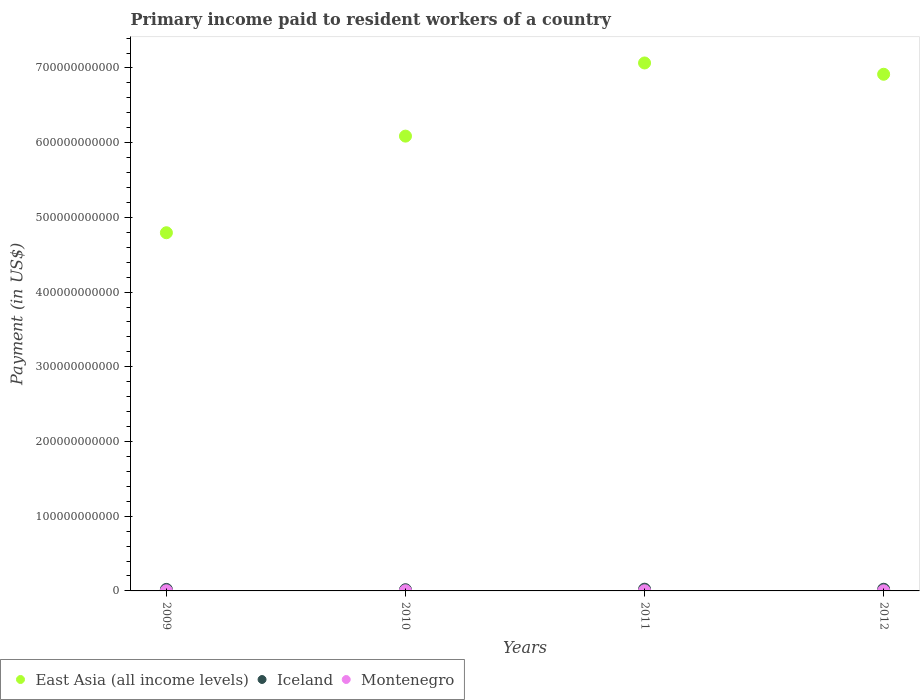Is the number of dotlines equal to the number of legend labels?
Ensure brevity in your answer.  Yes. What is the amount paid to workers in Iceland in 2011?
Provide a succinct answer. 2.31e+09. Across all years, what is the maximum amount paid to workers in Iceland?
Keep it short and to the point. 2.31e+09. Across all years, what is the minimum amount paid to workers in Iceland?
Give a very brief answer. 1.63e+09. In which year was the amount paid to workers in Iceland minimum?
Give a very brief answer. 2010. What is the total amount paid to workers in Iceland in the graph?
Provide a succinct answer. 8.19e+09. What is the difference between the amount paid to workers in Montenegro in 2009 and that in 2012?
Ensure brevity in your answer.  2.44e+07. What is the difference between the amount paid to workers in Iceland in 2011 and the amount paid to workers in Montenegro in 2012?
Provide a short and direct response. 2.12e+09. What is the average amount paid to workers in Montenegro per year?
Your answer should be very brief. 2.24e+08. In the year 2012, what is the difference between the amount paid to workers in Montenegro and amount paid to workers in Iceland?
Offer a very short reply. -2.03e+09. In how many years, is the amount paid to workers in East Asia (all income levels) greater than 660000000000 US$?
Keep it short and to the point. 2. What is the ratio of the amount paid to workers in Montenegro in 2009 to that in 2012?
Ensure brevity in your answer.  1.12. What is the difference between the highest and the second highest amount paid to workers in Montenegro?
Keep it short and to the point. 1.44e+07. What is the difference between the highest and the lowest amount paid to workers in East Asia (all income levels)?
Make the answer very short. 2.27e+11. In how many years, is the amount paid to workers in Iceland greater than the average amount paid to workers in Iceland taken over all years?
Provide a succinct answer. 2. Is it the case that in every year, the sum of the amount paid to workers in Montenegro and amount paid to workers in Iceland  is greater than the amount paid to workers in East Asia (all income levels)?
Keep it short and to the point. No. Is the amount paid to workers in Iceland strictly less than the amount paid to workers in Montenegro over the years?
Provide a short and direct response. No. How many years are there in the graph?
Your answer should be compact. 4. What is the difference between two consecutive major ticks on the Y-axis?
Your response must be concise. 1.00e+11. Does the graph contain grids?
Your answer should be compact. No. Where does the legend appear in the graph?
Make the answer very short. Bottom left. What is the title of the graph?
Offer a terse response. Primary income paid to resident workers of a country. What is the label or title of the Y-axis?
Your response must be concise. Payment (in US$). What is the Payment (in US$) of East Asia (all income levels) in 2009?
Give a very brief answer. 4.79e+11. What is the Payment (in US$) in Iceland in 2009?
Your answer should be compact. 2.02e+09. What is the Payment (in US$) in Montenegro in 2009?
Offer a terse response. 2.20e+08. What is the Payment (in US$) of East Asia (all income levels) in 2010?
Provide a succinct answer. 6.09e+11. What is the Payment (in US$) in Iceland in 2010?
Provide a succinct answer. 1.63e+09. What is the Payment (in US$) of Montenegro in 2010?
Ensure brevity in your answer.  2.47e+08. What is the Payment (in US$) in East Asia (all income levels) in 2011?
Provide a short and direct response. 7.07e+11. What is the Payment (in US$) in Iceland in 2011?
Your answer should be compact. 2.31e+09. What is the Payment (in US$) of Montenegro in 2011?
Offer a very short reply. 2.33e+08. What is the Payment (in US$) in East Asia (all income levels) in 2012?
Provide a short and direct response. 6.92e+11. What is the Payment (in US$) in Iceland in 2012?
Offer a terse response. 2.23e+09. What is the Payment (in US$) in Montenegro in 2012?
Your answer should be compact. 1.95e+08. Across all years, what is the maximum Payment (in US$) in East Asia (all income levels)?
Your answer should be compact. 7.07e+11. Across all years, what is the maximum Payment (in US$) of Iceland?
Ensure brevity in your answer.  2.31e+09. Across all years, what is the maximum Payment (in US$) in Montenegro?
Make the answer very short. 2.47e+08. Across all years, what is the minimum Payment (in US$) of East Asia (all income levels)?
Keep it short and to the point. 4.79e+11. Across all years, what is the minimum Payment (in US$) of Iceland?
Give a very brief answer. 1.63e+09. Across all years, what is the minimum Payment (in US$) of Montenegro?
Your response must be concise. 1.95e+08. What is the total Payment (in US$) of East Asia (all income levels) in the graph?
Ensure brevity in your answer.  2.49e+12. What is the total Payment (in US$) in Iceland in the graph?
Ensure brevity in your answer.  8.19e+09. What is the total Payment (in US$) of Montenegro in the graph?
Ensure brevity in your answer.  8.95e+08. What is the difference between the Payment (in US$) in East Asia (all income levels) in 2009 and that in 2010?
Your response must be concise. -1.29e+11. What is the difference between the Payment (in US$) in Iceland in 2009 and that in 2010?
Offer a terse response. 3.95e+08. What is the difference between the Payment (in US$) of Montenegro in 2009 and that in 2010?
Keep it short and to the point. -2.77e+07. What is the difference between the Payment (in US$) of East Asia (all income levels) in 2009 and that in 2011?
Offer a very short reply. -2.27e+11. What is the difference between the Payment (in US$) in Iceland in 2009 and that in 2011?
Provide a short and direct response. -2.94e+08. What is the difference between the Payment (in US$) in Montenegro in 2009 and that in 2011?
Offer a very short reply. -1.33e+07. What is the difference between the Payment (in US$) in East Asia (all income levels) in 2009 and that in 2012?
Offer a very short reply. -2.12e+11. What is the difference between the Payment (in US$) of Iceland in 2009 and that in 2012?
Provide a succinct answer. -2.10e+08. What is the difference between the Payment (in US$) in Montenegro in 2009 and that in 2012?
Your answer should be very brief. 2.44e+07. What is the difference between the Payment (in US$) of East Asia (all income levels) in 2010 and that in 2011?
Provide a succinct answer. -9.79e+1. What is the difference between the Payment (in US$) of Iceland in 2010 and that in 2011?
Your answer should be compact. -6.90e+08. What is the difference between the Payment (in US$) of Montenegro in 2010 and that in 2011?
Provide a succinct answer. 1.44e+07. What is the difference between the Payment (in US$) of East Asia (all income levels) in 2010 and that in 2012?
Your answer should be very brief. -8.28e+1. What is the difference between the Payment (in US$) of Iceland in 2010 and that in 2012?
Your answer should be very brief. -6.05e+08. What is the difference between the Payment (in US$) in Montenegro in 2010 and that in 2012?
Provide a short and direct response. 5.21e+07. What is the difference between the Payment (in US$) in East Asia (all income levels) in 2011 and that in 2012?
Keep it short and to the point. 1.51e+1. What is the difference between the Payment (in US$) of Iceland in 2011 and that in 2012?
Offer a terse response. 8.45e+07. What is the difference between the Payment (in US$) of Montenegro in 2011 and that in 2012?
Ensure brevity in your answer.  3.77e+07. What is the difference between the Payment (in US$) of East Asia (all income levels) in 2009 and the Payment (in US$) of Iceland in 2010?
Provide a short and direct response. 4.78e+11. What is the difference between the Payment (in US$) in East Asia (all income levels) in 2009 and the Payment (in US$) in Montenegro in 2010?
Make the answer very short. 4.79e+11. What is the difference between the Payment (in US$) in Iceland in 2009 and the Payment (in US$) in Montenegro in 2010?
Your response must be concise. 1.77e+09. What is the difference between the Payment (in US$) of East Asia (all income levels) in 2009 and the Payment (in US$) of Iceland in 2011?
Offer a very short reply. 4.77e+11. What is the difference between the Payment (in US$) of East Asia (all income levels) in 2009 and the Payment (in US$) of Montenegro in 2011?
Make the answer very short. 4.79e+11. What is the difference between the Payment (in US$) in Iceland in 2009 and the Payment (in US$) in Montenegro in 2011?
Give a very brief answer. 1.79e+09. What is the difference between the Payment (in US$) of East Asia (all income levels) in 2009 and the Payment (in US$) of Iceland in 2012?
Provide a succinct answer. 4.77e+11. What is the difference between the Payment (in US$) in East Asia (all income levels) in 2009 and the Payment (in US$) in Montenegro in 2012?
Make the answer very short. 4.79e+11. What is the difference between the Payment (in US$) in Iceland in 2009 and the Payment (in US$) in Montenegro in 2012?
Your response must be concise. 1.83e+09. What is the difference between the Payment (in US$) of East Asia (all income levels) in 2010 and the Payment (in US$) of Iceland in 2011?
Your response must be concise. 6.06e+11. What is the difference between the Payment (in US$) in East Asia (all income levels) in 2010 and the Payment (in US$) in Montenegro in 2011?
Provide a succinct answer. 6.09e+11. What is the difference between the Payment (in US$) in Iceland in 2010 and the Payment (in US$) in Montenegro in 2011?
Offer a terse response. 1.39e+09. What is the difference between the Payment (in US$) of East Asia (all income levels) in 2010 and the Payment (in US$) of Iceland in 2012?
Make the answer very short. 6.07e+11. What is the difference between the Payment (in US$) in East Asia (all income levels) in 2010 and the Payment (in US$) in Montenegro in 2012?
Offer a terse response. 6.09e+11. What is the difference between the Payment (in US$) in Iceland in 2010 and the Payment (in US$) in Montenegro in 2012?
Offer a terse response. 1.43e+09. What is the difference between the Payment (in US$) in East Asia (all income levels) in 2011 and the Payment (in US$) in Iceland in 2012?
Ensure brevity in your answer.  7.04e+11. What is the difference between the Payment (in US$) of East Asia (all income levels) in 2011 and the Payment (in US$) of Montenegro in 2012?
Provide a succinct answer. 7.06e+11. What is the difference between the Payment (in US$) in Iceland in 2011 and the Payment (in US$) in Montenegro in 2012?
Your answer should be very brief. 2.12e+09. What is the average Payment (in US$) of East Asia (all income levels) per year?
Ensure brevity in your answer.  6.22e+11. What is the average Payment (in US$) in Iceland per year?
Your answer should be compact. 2.05e+09. What is the average Payment (in US$) of Montenegro per year?
Make the answer very short. 2.24e+08. In the year 2009, what is the difference between the Payment (in US$) of East Asia (all income levels) and Payment (in US$) of Iceland?
Make the answer very short. 4.77e+11. In the year 2009, what is the difference between the Payment (in US$) in East Asia (all income levels) and Payment (in US$) in Montenegro?
Give a very brief answer. 4.79e+11. In the year 2009, what is the difference between the Payment (in US$) in Iceland and Payment (in US$) in Montenegro?
Ensure brevity in your answer.  1.80e+09. In the year 2010, what is the difference between the Payment (in US$) of East Asia (all income levels) and Payment (in US$) of Iceland?
Your answer should be very brief. 6.07e+11. In the year 2010, what is the difference between the Payment (in US$) of East Asia (all income levels) and Payment (in US$) of Montenegro?
Your response must be concise. 6.09e+11. In the year 2010, what is the difference between the Payment (in US$) of Iceland and Payment (in US$) of Montenegro?
Your response must be concise. 1.38e+09. In the year 2011, what is the difference between the Payment (in US$) in East Asia (all income levels) and Payment (in US$) in Iceland?
Your answer should be very brief. 7.04e+11. In the year 2011, what is the difference between the Payment (in US$) in East Asia (all income levels) and Payment (in US$) in Montenegro?
Your answer should be very brief. 7.06e+11. In the year 2011, what is the difference between the Payment (in US$) of Iceland and Payment (in US$) of Montenegro?
Give a very brief answer. 2.08e+09. In the year 2012, what is the difference between the Payment (in US$) in East Asia (all income levels) and Payment (in US$) in Iceland?
Your response must be concise. 6.89e+11. In the year 2012, what is the difference between the Payment (in US$) in East Asia (all income levels) and Payment (in US$) in Montenegro?
Provide a succinct answer. 6.91e+11. In the year 2012, what is the difference between the Payment (in US$) in Iceland and Payment (in US$) in Montenegro?
Your answer should be very brief. 2.03e+09. What is the ratio of the Payment (in US$) of East Asia (all income levels) in 2009 to that in 2010?
Your response must be concise. 0.79. What is the ratio of the Payment (in US$) of Iceland in 2009 to that in 2010?
Your response must be concise. 1.24. What is the ratio of the Payment (in US$) in Montenegro in 2009 to that in 2010?
Your answer should be very brief. 0.89. What is the ratio of the Payment (in US$) of East Asia (all income levels) in 2009 to that in 2011?
Offer a terse response. 0.68. What is the ratio of the Payment (in US$) of Iceland in 2009 to that in 2011?
Offer a very short reply. 0.87. What is the ratio of the Payment (in US$) of Montenegro in 2009 to that in 2011?
Offer a very short reply. 0.94. What is the ratio of the Payment (in US$) of East Asia (all income levels) in 2009 to that in 2012?
Give a very brief answer. 0.69. What is the ratio of the Payment (in US$) in Iceland in 2009 to that in 2012?
Your answer should be very brief. 0.91. What is the ratio of the Payment (in US$) in Montenegro in 2009 to that in 2012?
Provide a short and direct response. 1.12. What is the ratio of the Payment (in US$) of East Asia (all income levels) in 2010 to that in 2011?
Make the answer very short. 0.86. What is the ratio of the Payment (in US$) of Iceland in 2010 to that in 2011?
Your answer should be very brief. 0.7. What is the ratio of the Payment (in US$) in Montenegro in 2010 to that in 2011?
Give a very brief answer. 1.06. What is the ratio of the Payment (in US$) in East Asia (all income levels) in 2010 to that in 2012?
Make the answer very short. 0.88. What is the ratio of the Payment (in US$) of Iceland in 2010 to that in 2012?
Ensure brevity in your answer.  0.73. What is the ratio of the Payment (in US$) in Montenegro in 2010 to that in 2012?
Your response must be concise. 1.27. What is the ratio of the Payment (in US$) in East Asia (all income levels) in 2011 to that in 2012?
Offer a very short reply. 1.02. What is the ratio of the Payment (in US$) of Iceland in 2011 to that in 2012?
Ensure brevity in your answer.  1.04. What is the ratio of the Payment (in US$) of Montenegro in 2011 to that in 2012?
Your answer should be compact. 1.19. What is the difference between the highest and the second highest Payment (in US$) of East Asia (all income levels)?
Your answer should be compact. 1.51e+1. What is the difference between the highest and the second highest Payment (in US$) of Iceland?
Ensure brevity in your answer.  8.45e+07. What is the difference between the highest and the second highest Payment (in US$) in Montenegro?
Ensure brevity in your answer.  1.44e+07. What is the difference between the highest and the lowest Payment (in US$) in East Asia (all income levels)?
Your answer should be compact. 2.27e+11. What is the difference between the highest and the lowest Payment (in US$) in Iceland?
Provide a short and direct response. 6.90e+08. What is the difference between the highest and the lowest Payment (in US$) of Montenegro?
Provide a short and direct response. 5.21e+07. 